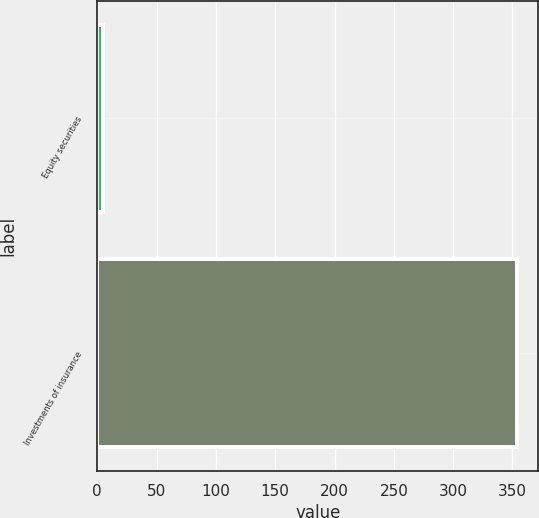Convert chart to OTSL. <chart><loc_0><loc_0><loc_500><loc_500><bar_chart><fcel>Equity securities<fcel>Investments of insurance<nl><fcel>5<fcel>354<nl></chart> 